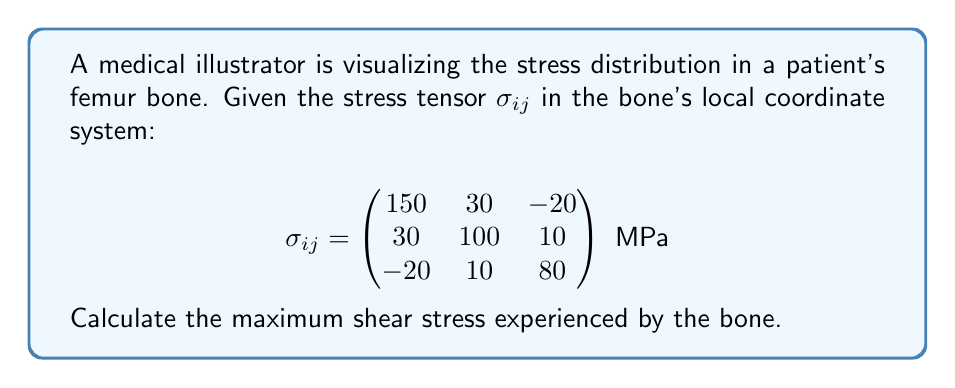Can you solve this math problem? To find the maximum shear stress, we need to follow these steps:

1) First, we need to calculate the principal stresses. These are the eigenvalues of the stress tensor.

2) The characteristic equation for the eigenvalues is:
   $$\det(\sigma_{ij} - \lambda I) = 0$$

3) Expanding this determinant:
   $$\begin{vmatrix}
   150-\lambda & 30 & -20 \\
   30 & 100-\lambda & 10 \\
   -20 & 10 & 80-\lambda
   \end{vmatrix} = 0$$

4) This leads to the cubic equation:
   $$-\lambda^3 + 330\lambda^2 - 35100\lambda + 1230000 = 0$$

5) Solving this equation (using a calculator or computer algebra system) gives the principal stresses:
   $$\lambda_1 \approx 170.7 \text{ MPa}$$
   $$\lambda_2 \approx 103.0 \text{ MPa}$$
   $$\lambda_3 \approx 56.3 \text{ MPa}$$

6) The maximum shear stress $\tau_{max}$ is given by half the difference between the maximum and minimum principal stresses:
   $$\tau_{max} = \frac{1}{2}(\lambda_{max} - \lambda_{min}) = \frac{1}{2}(170.7 - 56.3) = 57.2 \text{ MPa}$$

Therefore, the maximum shear stress in the bone is approximately 57.2 MPa.
Answer: $57.2 \text{ MPa}$ 